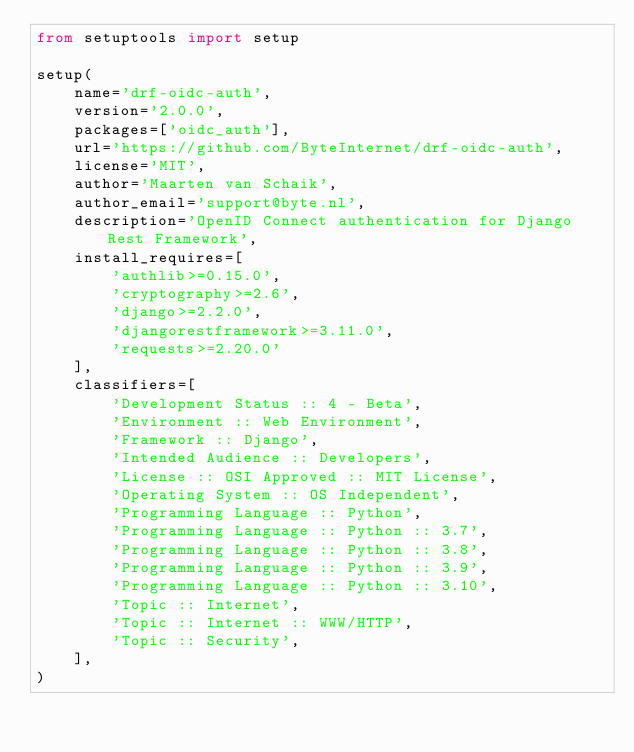<code> <loc_0><loc_0><loc_500><loc_500><_Python_>from setuptools import setup

setup(
    name='drf-oidc-auth',
    version='2.0.0',
    packages=['oidc_auth'],
    url='https://github.com/ByteInternet/drf-oidc-auth',
    license='MIT',
    author='Maarten van Schaik',
    author_email='support@byte.nl',
    description='OpenID Connect authentication for Django Rest Framework',
    install_requires=[
        'authlib>=0.15.0',
        'cryptography>=2.6',
        'django>=2.2.0',
        'djangorestframework>=3.11.0',
        'requests>=2.20.0'
    ],
    classifiers=[
        'Development Status :: 4 - Beta',
        'Environment :: Web Environment',
        'Framework :: Django',
        'Intended Audience :: Developers',
        'License :: OSI Approved :: MIT License',
        'Operating System :: OS Independent',
        'Programming Language :: Python',
        'Programming Language :: Python :: 3.7',
        'Programming Language :: Python :: 3.8',
        'Programming Language :: Python :: 3.9',
        'Programming Language :: Python :: 3.10',
        'Topic :: Internet',
        'Topic :: Internet :: WWW/HTTP',
        'Topic :: Security',
    ],
)
</code> 